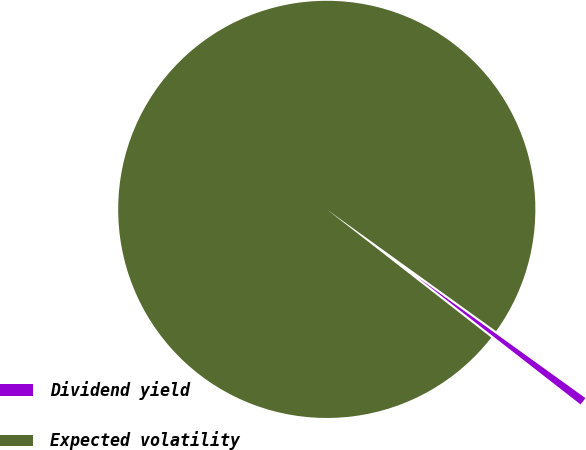<chart> <loc_0><loc_0><loc_500><loc_500><pie_chart><fcel>Dividend yield<fcel>Expected volatility<nl><fcel>0.61%<fcel>99.39%<nl></chart> 